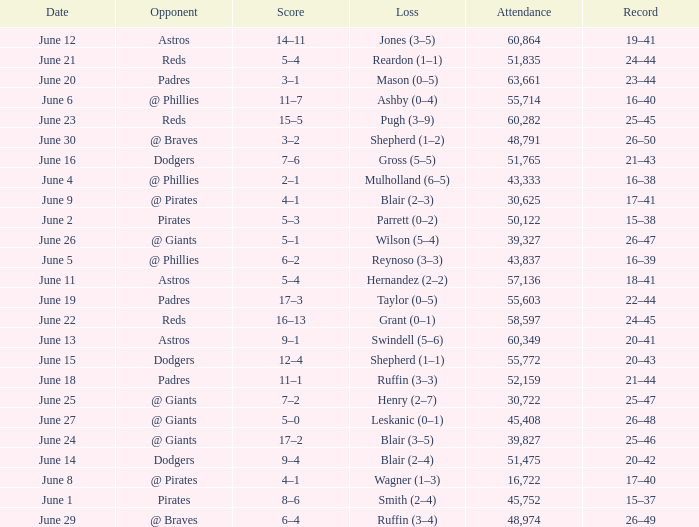What was the score on June 12? 14–11. Could you parse the entire table as a dict? {'header': ['Date', 'Opponent', 'Score', 'Loss', 'Attendance', 'Record'], 'rows': [['June 12', 'Astros', '14–11', 'Jones (3–5)', '60,864', '19–41'], ['June 21', 'Reds', '5–4', 'Reardon (1–1)', '51,835', '24–44'], ['June 20', 'Padres', '3–1', 'Mason (0–5)', '63,661', '23–44'], ['June 6', '@ Phillies', '11–7', 'Ashby (0–4)', '55,714', '16–40'], ['June 23', 'Reds', '15–5', 'Pugh (3–9)', '60,282', '25–45'], ['June 30', '@ Braves', '3–2', 'Shepherd (1–2)', '48,791', '26–50'], ['June 16', 'Dodgers', '7–6', 'Gross (5–5)', '51,765', '21–43'], ['June 4', '@ Phillies', '2–1', 'Mulholland (6–5)', '43,333', '16–38'], ['June 9', '@ Pirates', '4–1', 'Blair (2–3)', '30,625', '17–41'], ['June 2', 'Pirates', '5–3', 'Parrett (0–2)', '50,122', '15–38'], ['June 26', '@ Giants', '5–1', 'Wilson (5–4)', '39,327', '26–47'], ['June 5', '@ Phillies', '6–2', 'Reynoso (3–3)', '43,837', '16–39'], ['June 11', 'Astros', '5–4', 'Hernandez (2–2)', '57,136', '18–41'], ['June 19', 'Padres', '17–3', 'Taylor (0–5)', '55,603', '22–44'], ['June 22', 'Reds', '16–13', 'Grant (0–1)', '58,597', '24–45'], ['June 13', 'Astros', '9–1', 'Swindell (5–6)', '60,349', '20–41'], ['June 15', 'Dodgers', '12–4', 'Shepherd (1–1)', '55,772', '20–43'], ['June 18', 'Padres', '11–1', 'Ruffin (3–3)', '52,159', '21–44'], ['June 25', '@ Giants', '7–2', 'Henry (2–7)', '30,722', '25–47'], ['June 27', '@ Giants', '5–0', 'Leskanic (0–1)', '45,408', '26–48'], ['June 24', '@ Giants', '17–2', 'Blair (3–5)', '39,827', '25–46'], ['June 14', 'Dodgers', '9–4', 'Blair (2–4)', '51,475', '20–42'], ['June 8', '@ Pirates', '4–1', 'Wagner (1–3)', '16,722', '17–40'], ['June 1', 'Pirates', '8–6', 'Smith (2–4)', '45,752', '15–37'], ['June 29', '@ Braves', '6–4', 'Ruffin (3–4)', '48,974', '26–49']]} 